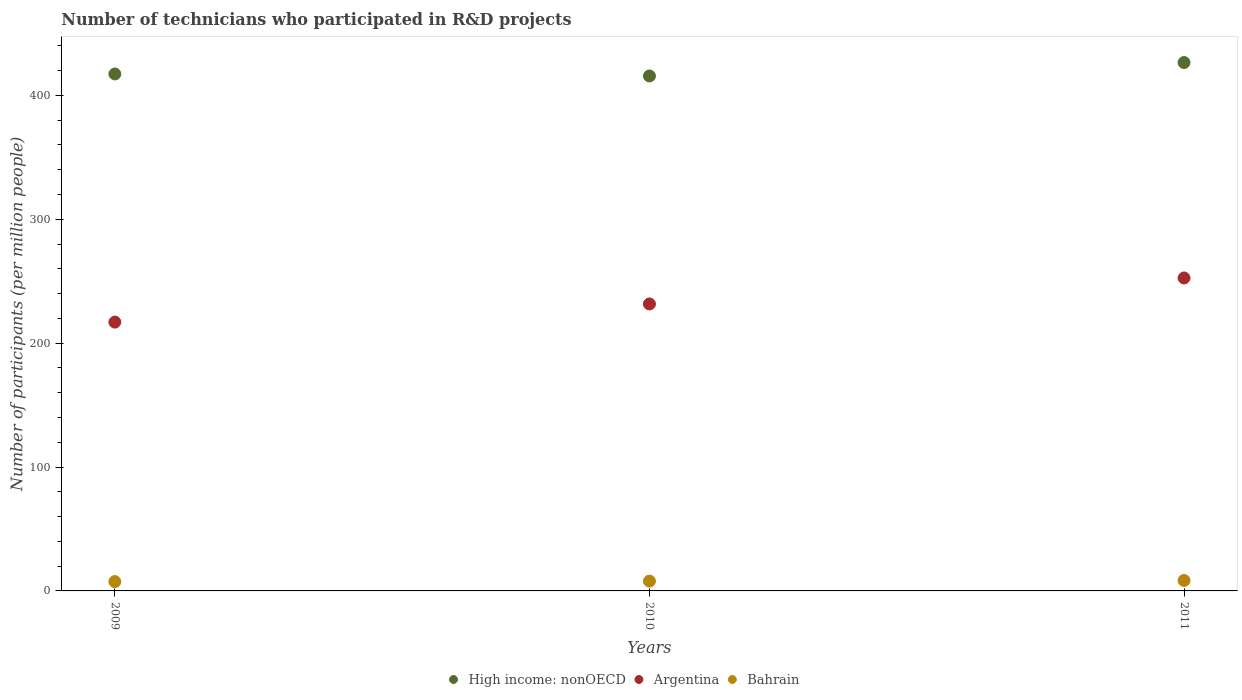What is the number of technicians who participated in R&D projects in High income: nonOECD in 2010?
Offer a terse response. 415.62. Across all years, what is the maximum number of technicians who participated in R&D projects in Argentina?
Ensure brevity in your answer.  252.58. Across all years, what is the minimum number of technicians who participated in R&D projects in Bahrain?
Keep it short and to the point. 7.52. In which year was the number of technicians who participated in R&D projects in High income: nonOECD maximum?
Your answer should be compact. 2011. In which year was the number of technicians who participated in R&D projects in Bahrain minimum?
Offer a very short reply. 2009. What is the total number of technicians who participated in R&D projects in Bahrain in the graph?
Your response must be concise. 23.87. What is the difference between the number of technicians who participated in R&D projects in High income: nonOECD in 2009 and that in 2011?
Your answer should be compact. -9.23. What is the difference between the number of technicians who participated in R&D projects in High income: nonOECD in 2011 and the number of technicians who participated in R&D projects in Bahrain in 2010?
Provide a succinct answer. 418.54. What is the average number of technicians who participated in R&D projects in Argentina per year?
Offer a very short reply. 233.72. In the year 2011, what is the difference between the number of technicians who participated in R&D projects in Argentina and number of technicians who participated in R&D projects in High income: nonOECD?
Provide a short and direct response. -173.89. In how many years, is the number of technicians who participated in R&D projects in High income: nonOECD greater than 380?
Your answer should be compact. 3. What is the ratio of the number of technicians who participated in R&D projects in Argentina in 2009 to that in 2011?
Offer a very short reply. 0.86. What is the difference between the highest and the second highest number of technicians who participated in R&D projects in Bahrain?
Ensure brevity in your answer.  0.49. What is the difference between the highest and the lowest number of technicians who participated in R&D projects in High income: nonOECD?
Keep it short and to the point. 10.84. In how many years, is the number of technicians who participated in R&D projects in Argentina greater than the average number of technicians who participated in R&D projects in Argentina taken over all years?
Provide a short and direct response. 1. Is the sum of the number of technicians who participated in R&D projects in Bahrain in 2009 and 2011 greater than the maximum number of technicians who participated in R&D projects in Argentina across all years?
Keep it short and to the point. No. Does the number of technicians who participated in R&D projects in Argentina monotonically increase over the years?
Ensure brevity in your answer.  Yes. How many dotlines are there?
Provide a short and direct response. 3. How many years are there in the graph?
Ensure brevity in your answer.  3. Are the values on the major ticks of Y-axis written in scientific E-notation?
Give a very brief answer. No. Where does the legend appear in the graph?
Keep it short and to the point. Bottom center. What is the title of the graph?
Offer a very short reply. Number of technicians who participated in R&D projects. Does "Brazil" appear as one of the legend labels in the graph?
Keep it short and to the point. No. What is the label or title of the X-axis?
Your response must be concise. Years. What is the label or title of the Y-axis?
Give a very brief answer. Number of participants (per million people). What is the Number of participants (per million people) of High income: nonOECD in 2009?
Offer a very short reply. 417.23. What is the Number of participants (per million people) in Argentina in 2009?
Give a very brief answer. 216.97. What is the Number of participants (per million people) of Bahrain in 2009?
Provide a short and direct response. 7.52. What is the Number of participants (per million people) in High income: nonOECD in 2010?
Your answer should be very brief. 415.62. What is the Number of participants (per million people) in Argentina in 2010?
Ensure brevity in your answer.  231.62. What is the Number of participants (per million people) in Bahrain in 2010?
Ensure brevity in your answer.  7.93. What is the Number of participants (per million people) in High income: nonOECD in 2011?
Your answer should be compact. 426.47. What is the Number of participants (per million people) of Argentina in 2011?
Keep it short and to the point. 252.58. What is the Number of participants (per million people) of Bahrain in 2011?
Ensure brevity in your answer.  8.42. Across all years, what is the maximum Number of participants (per million people) of High income: nonOECD?
Provide a short and direct response. 426.47. Across all years, what is the maximum Number of participants (per million people) of Argentina?
Make the answer very short. 252.58. Across all years, what is the maximum Number of participants (per million people) in Bahrain?
Keep it short and to the point. 8.42. Across all years, what is the minimum Number of participants (per million people) of High income: nonOECD?
Your response must be concise. 415.62. Across all years, what is the minimum Number of participants (per million people) of Argentina?
Make the answer very short. 216.97. Across all years, what is the minimum Number of participants (per million people) of Bahrain?
Your answer should be very brief. 7.52. What is the total Number of participants (per million people) in High income: nonOECD in the graph?
Your answer should be compact. 1259.33. What is the total Number of participants (per million people) of Argentina in the graph?
Offer a very short reply. 701.16. What is the total Number of participants (per million people) of Bahrain in the graph?
Ensure brevity in your answer.  23.87. What is the difference between the Number of participants (per million people) in High income: nonOECD in 2009 and that in 2010?
Offer a terse response. 1.61. What is the difference between the Number of participants (per million people) of Argentina in 2009 and that in 2010?
Keep it short and to the point. -14.65. What is the difference between the Number of participants (per million people) of Bahrain in 2009 and that in 2010?
Provide a short and direct response. -0.41. What is the difference between the Number of participants (per million people) of High income: nonOECD in 2009 and that in 2011?
Keep it short and to the point. -9.23. What is the difference between the Number of participants (per million people) in Argentina in 2009 and that in 2011?
Provide a short and direct response. -35.61. What is the difference between the Number of participants (per million people) of Bahrain in 2009 and that in 2011?
Keep it short and to the point. -0.9. What is the difference between the Number of participants (per million people) in High income: nonOECD in 2010 and that in 2011?
Your answer should be compact. -10.84. What is the difference between the Number of participants (per million people) in Argentina in 2010 and that in 2011?
Provide a short and direct response. -20.96. What is the difference between the Number of participants (per million people) of Bahrain in 2010 and that in 2011?
Offer a terse response. -0.49. What is the difference between the Number of participants (per million people) in High income: nonOECD in 2009 and the Number of participants (per million people) in Argentina in 2010?
Give a very brief answer. 185.61. What is the difference between the Number of participants (per million people) in High income: nonOECD in 2009 and the Number of participants (per million people) in Bahrain in 2010?
Your answer should be very brief. 409.31. What is the difference between the Number of participants (per million people) in Argentina in 2009 and the Number of participants (per million people) in Bahrain in 2010?
Ensure brevity in your answer.  209.04. What is the difference between the Number of participants (per million people) in High income: nonOECD in 2009 and the Number of participants (per million people) in Argentina in 2011?
Provide a short and direct response. 164.66. What is the difference between the Number of participants (per million people) of High income: nonOECD in 2009 and the Number of participants (per million people) of Bahrain in 2011?
Provide a succinct answer. 408.81. What is the difference between the Number of participants (per million people) of Argentina in 2009 and the Number of participants (per million people) of Bahrain in 2011?
Keep it short and to the point. 208.55. What is the difference between the Number of participants (per million people) in High income: nonOECD in 2010 and the Number of participants (per million people) in Argentina in 2011?
Keep it short and to the point. 163.05. What is the difference between the Number of participants (per million people) in High income: nonOECD in 2010 and the Number of participants (per million people) in Bahrain in 2011?
Ensure brevity in your answer.  407.2. What is the difference between the Number of participants (per million people) in Argentina in 2010 and the Number of participants (per million people) in Bahrain in 2011?
Keep it short and to the point. 223.2. What is the average Number of participants (per million people) of High income: nonOECD per year?
Your answer should be very brief. 419.78. What is the average Number of participants (per million people) of Argentina per year?
Provide a succinct answer. 233.72. What is the average Number of participants (per million people) in Bahrain per year?
Offer a terse response. 7.96. In the year 2009, what is the difference between the Number of participants (per million people) of High income: nonOECD and Number of participants (per million people) of Argentina?
Keep it short and to the point. 200.27. In the year 2009, what is the difference between the Number of participants (per million people) in High income: nonOECD and Number of participants (per million people) in Bahrain?
Offer a very short reply. 409.71. In the year 2009, what is the difference between the Number of participants (per million people) in Argentina and Number of participants (per million people) in Bahrain?
Your answer should be compact. 209.45. In the year 2010, what is the difference between the Number of participants (per million people) in High income: nonOECD and Number of participants (per million people) in Argentina?
Provide a succinct answer. 184.01. In the year 2010, what is the difference between the Number of participants (per million people) of High income: nonOECD and Number of participants (per million people) of Bahrain?
Make the answer very short. 407.7. In the year 2010, what is the difference between the Number of participants (per million people) of Argentina and Number of participants (per million people) of Bahrain?
Keep it short and to the point. 223.69. In the year 2011, what is the difference between the Number of participants (per million people) in High income: nonOECD and Number of participants (per million people) in Argentina?
Your answer should be very brief. 173.89. In the year 2011, what is the difference between the Number of participants (per million people) of High income: nonOECD and Number of participants (per million people) of Bahrain?
Keep it short and to the point. 418.05. In the year 2011, what is the difference between the Number of participants (per million people) in Argentina and Number of participants (per million people) in Bahrain?
Your answer should be very brief. 244.15. What is the ratio of the Number of participants (per million people) in Argentina in 2009 to that in 2010?
Offer a terse response. 0.94. What is the ratio of the Number of participants (per million people) in Bahrain in 2009 to that in 2010?
Offer a terse response. 0.95. What is the ratio of the Number of participants (per million people) of High income: nonOECD in 2009 to that in 2011?
Keep it short and to the point. 0.98. What is the ratio of the Number of participants (per million people) of Argentina in 2009 to that in 2011?
Make the answer very short. 0.86. What is the ratio of the Number of participants (per million people) of Bahrain in 2009 to that in 2011?
Keep it short and to the point. 0.89. What is the ratio of the Number of participants (per million people) in High income: nonOECD in 2010 to that in 2011?
Your response must be concise. 0.97. What is the ratio of the Number of participants (per million people) of Argentina in 2010 to that in 2011?
Offer a very short reply. 0.92. What is the ratio of the Number of participants (per million people) of Bahrain in 2010 to that in 2011?
Provide a succinct answer. 0.94. What is the difference between the highest and the second highest Number of participants (per million people) in High income: nonOECD?
Keep it short and to the point. 9.23. What is the difference between the highest and the second highest Number of participants (per million people) in Argentina?
Keep it short and to the point. 20.96. What is the difference between the highest and the second highest Number of participants (per million people) in Bahrain?
Keep it short and to the point. 0.49. What is the difference between the highest and the lowest Number of participants (per million people) of High income: nonOECD?
Keep it short and to the point. 10.84. What is the difference between the highest and the lowest Number of participants (per million people) in Argentina?
Provide a short and direct response. 35.61. What is the difference between the highest and the lowest Number of participants (per million people) of Bahrain?
Keep it short and to the point. 0.9. 